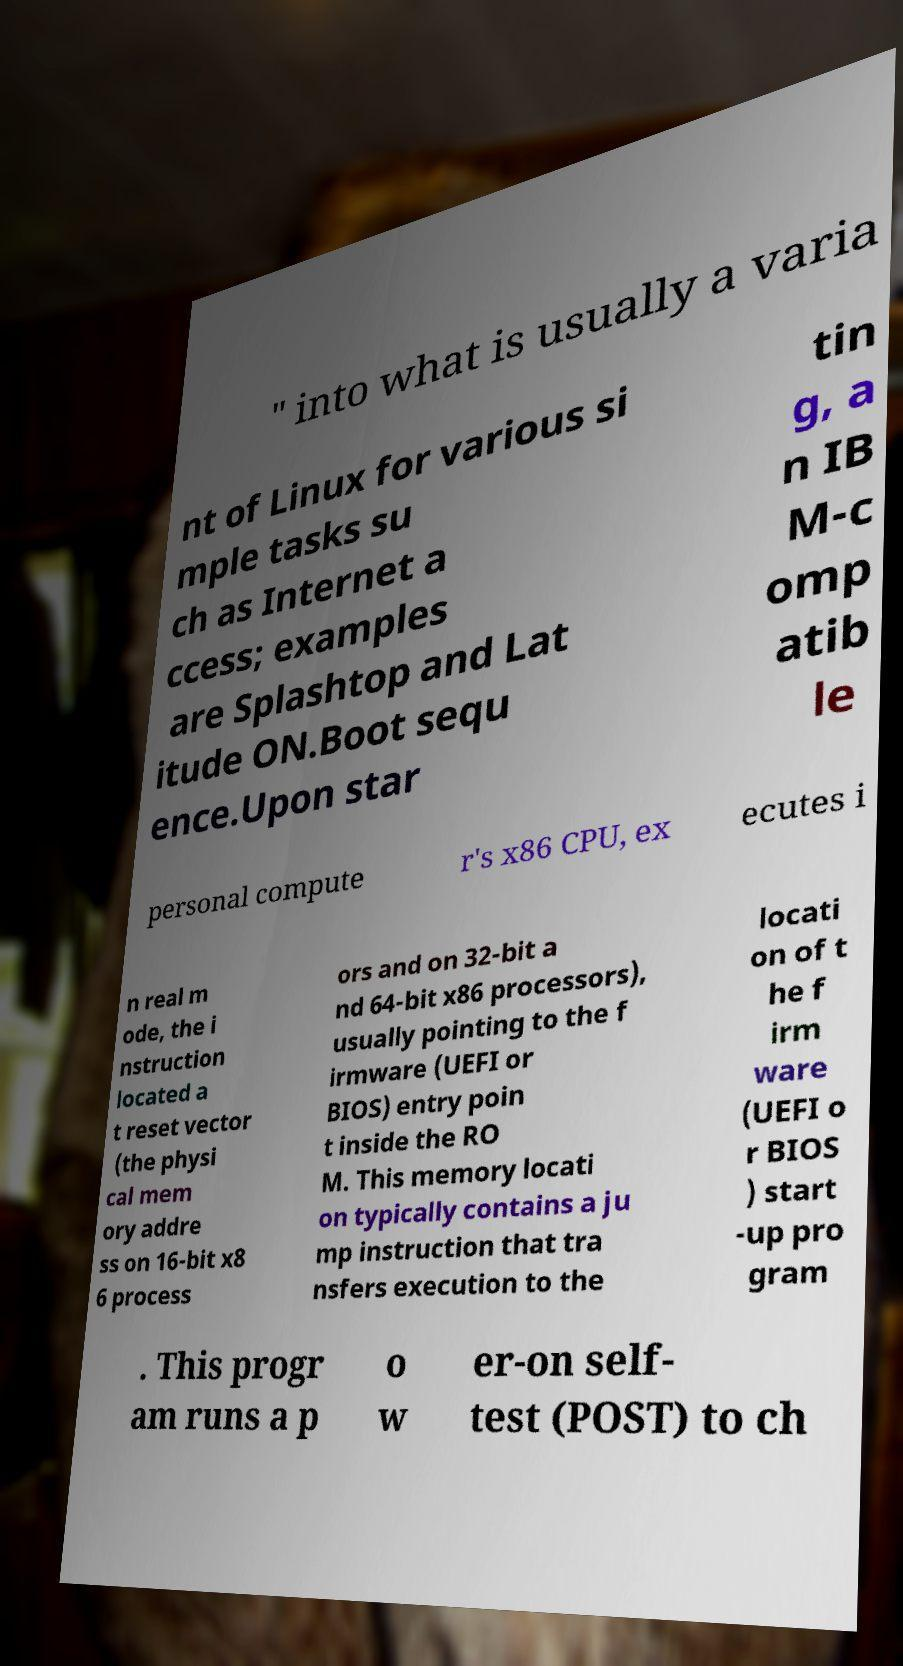Could you assist in decoding the text presented in this image and type it out clearly? " into what is usually a varia nt of Linux for various si mple tasks su ch as Internet a ccess; examples are Splashtop and Lat itude ON.Boot sequ ence.Upon star tin g, a n IB M-c omp atib le personal compute r's x86 CPU, ex ecutes i n real m ode, the i nstruction located a t reset vector (the physi cal mem ory addre ss on 16-bit x8 6 process ors and on 32-bit a nd 64-bit x86 processors), usually pointing to the f irmware (UEFI or BIOS) entry poin t inside the RO M. This memory locati on typically contains a ju mp instruction that tra nsfers execution to the locati on of t he f irm ware (UEFI o r BIOS ) start -up pro gram . This progr am runs a p o w er-on self- test (POST) to ch 